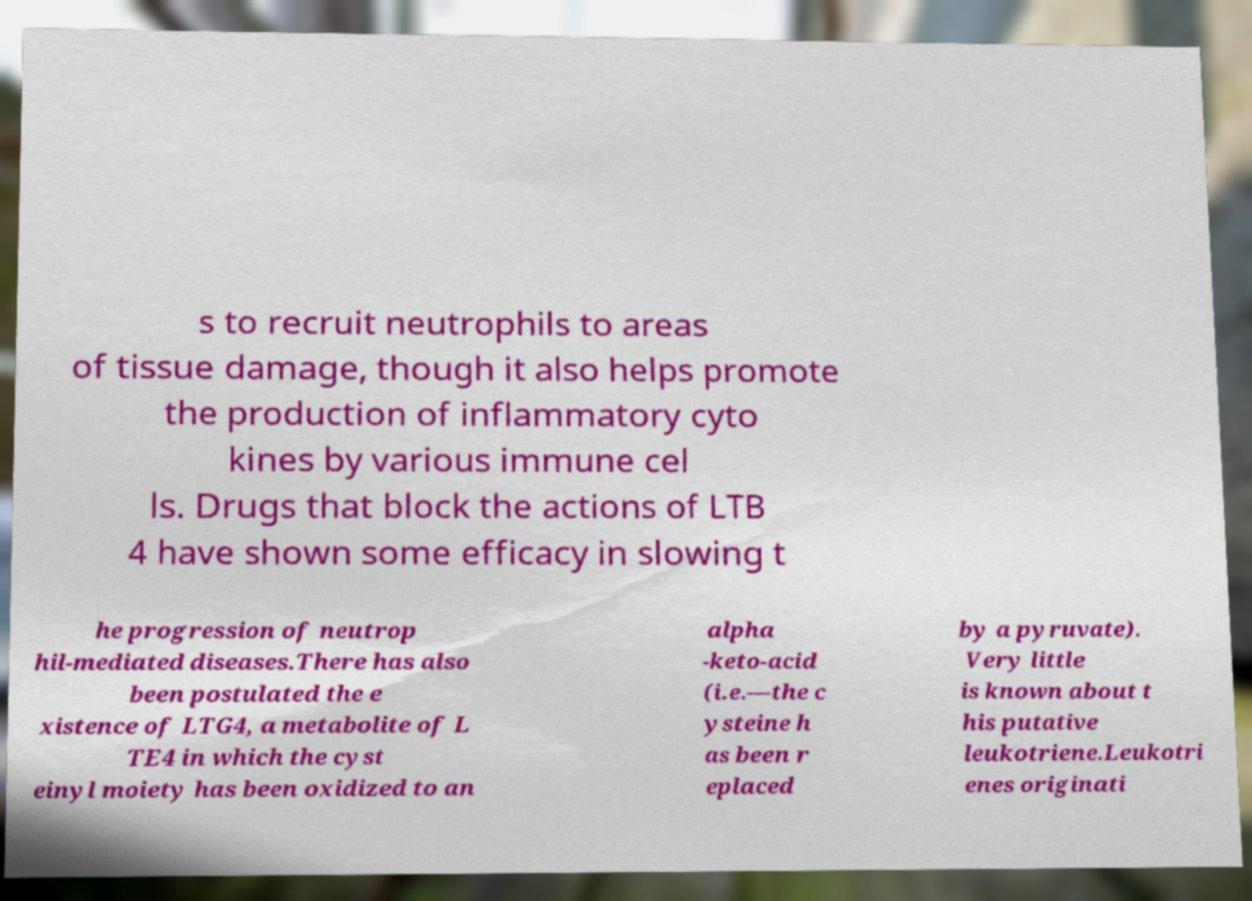For documentation purposes, I need the text within this image transcribed. Could you provide that? s to recruit neutrophils to areas of tissue damage, though it also helps promote the production of inflammatory cyto kines by various immune cel ls. Drugs that block the actions of LTB 4 have shown some efficacy in slowing t he progression of neutrop hil-mediated diseases.There has also been postulated the e xistence of LTG4, a metabolite of L TE4 in which the cyst einyl moiety has been oxidized to an alpha -keto-acid (i.e.—the c ysteine h as been r eplaced by a pyruvate). Very little is known about t his putative leukotriene.Leukotri enes originati 